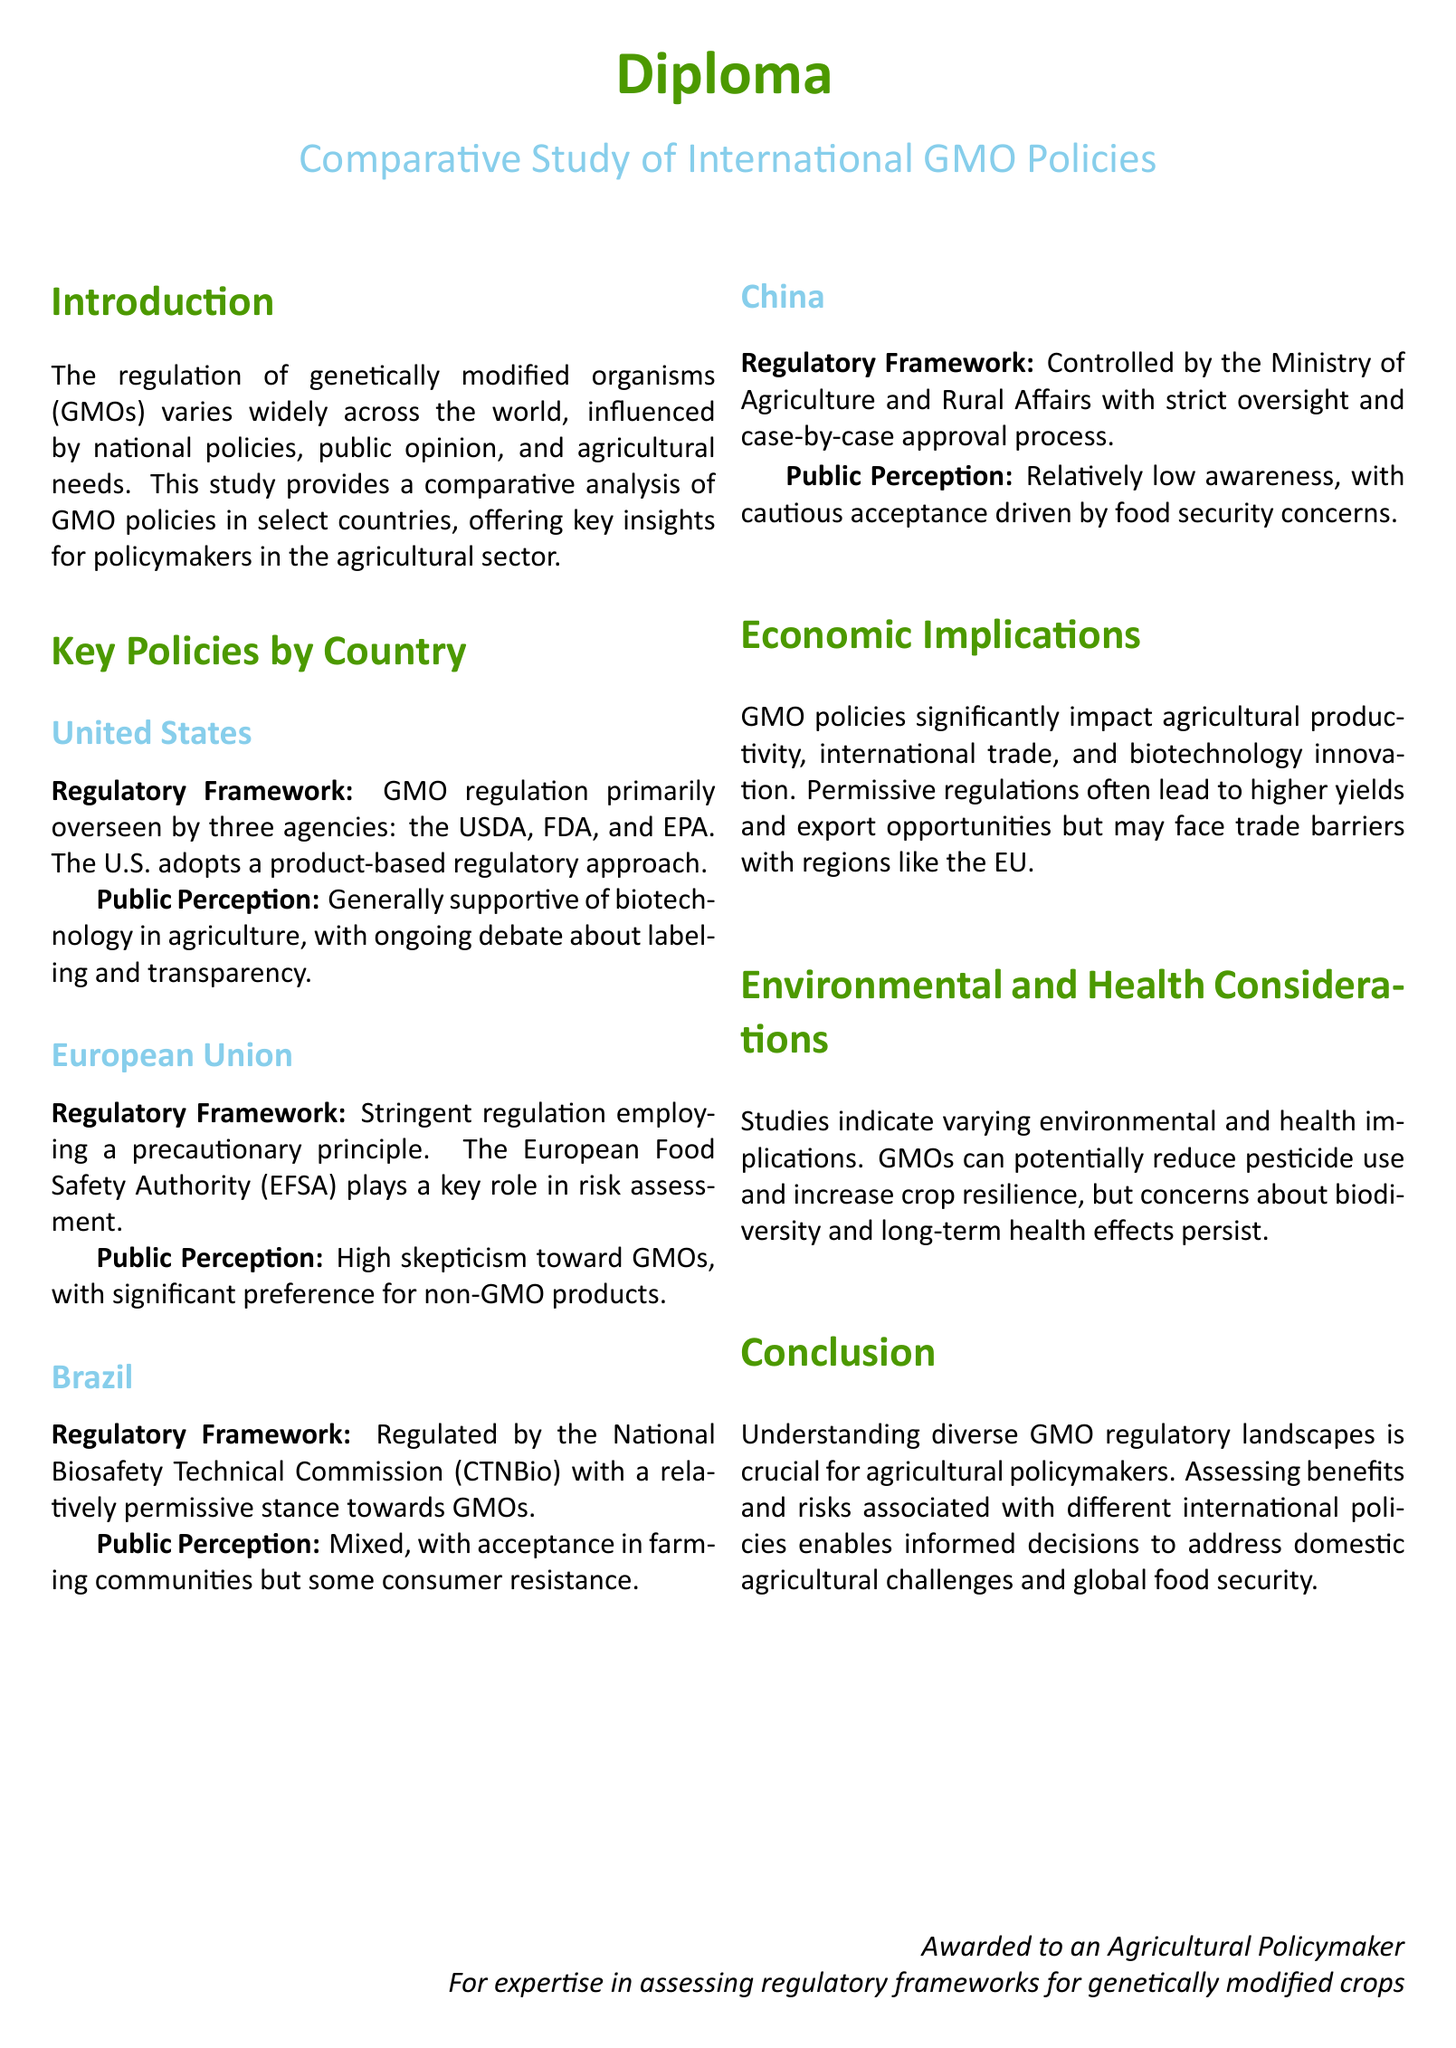What are the three agencies that oversee GMO regulation in the United States? The three agencies responsible for GMO regulation in the U.S. are the USDA, FDA, and EPA.
Answer: USDA, FDA, EPA What principle does the European Union's regulatory framework employ? The regulatory framework of the European Union employs the precautionary principle.
Answer: Precautionary principle What is the mixed public perception of GMOs in Brazil characterized by? The public perception in Brazil is characterized by acceptance in farming communities but some consumer resistance.
Answer: Acceptance in farming communities but some consumer resistance Which authority plays a key role in risk assessment for the EU? The European Food Safety Authority (EFSA) plays a key role in risk assessment.
Answer: EFSA What are two significant economic implications mentioned regarding GMO policies? The economic implications include impact on agricultural productivity and international trade.
Answer: Agricultural productivity and international trade What does China's case-by-case approval process refer to? The case-by-case approval process in China refers to the strict oversight of GMO regulation by the Ministry of Agriculture and Rural Affairs.
Answer: Strict oversight and case-by-case approval What is the primary benefit potential of GMOs indicated in the document? The document indicates that GMOs can potentially reduce pesticide use and increase crop resilience.
Answer: Reduce pesticide use and increase crop resilience Who was awarded the diploma according to the document? The diploma is awarded to an Agricultural Policymaker, specifically for expertise in assessing regulatory frameworks for genetically modified crops.
Answer: An Agricultural Policymaker What type of analysis does the diploma provide for policymakers? The diploma provides a comparative analysis of GMO policies in select countries.
Answer: Comparative analysis of GMO policies 